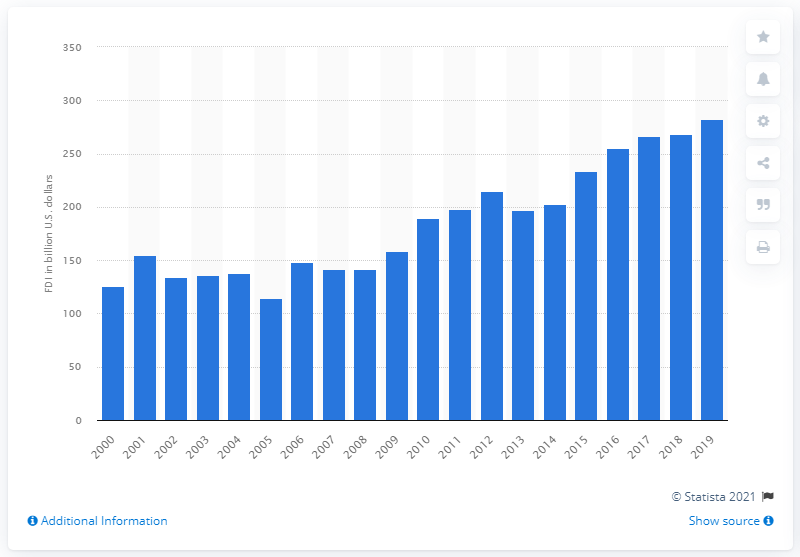Highlight a few significant elements in this photo. In 2019, the amount of French foreign direct investments in the United States was 282.23. 